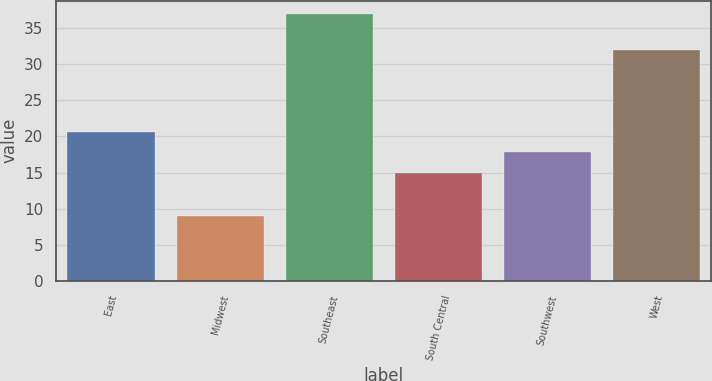Convert chart to OTSL. <chart><loc_0><loc_0><loc_500><loc_500><bar_chart><fcel>East<fcel>Midwest<fcel>Southeast<fcel>South Central<fcel>Southwest<fcel>West<nl><fcel>20.6<fcel>9<fcel>37<fcel>15<fcel>17.8<fcel>32<nl></chart> 